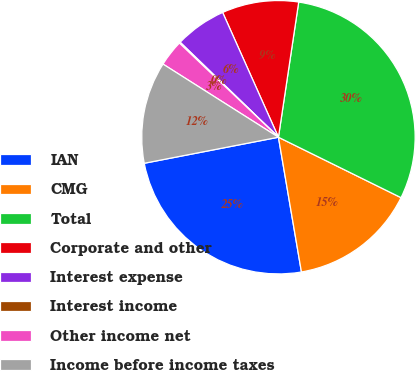Convert chart to OTSL. <chart><loc_0><loc_0><loc_500><loc_500><pie_chart><fcel>IAN<fcel>CMG<fcel>Total<fcel>Corporate and other<fcel>Interest expense<fcel>Interest income<fcel>Other income net<fcel>Income before income taxes<nl><fcel>24.64%<fcel>15.02%<fcel>29.92%<fcel>9.06%<fcel>6.08%<fcel>0.13%<fcel>3.11%<fcel>12.04%<nl></chart> 